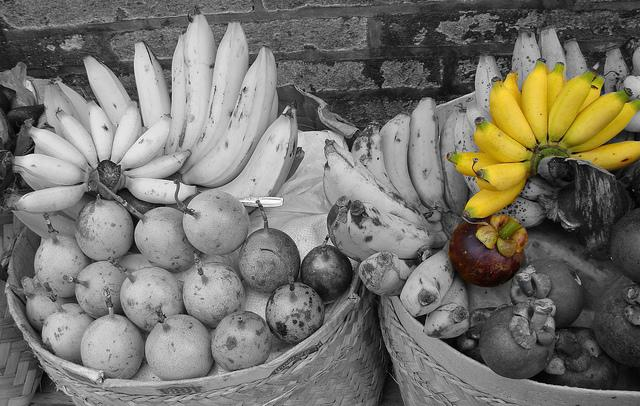Where is this produce located? Please explain your reasoning. market. The produce looks to be on display at an outdoor venue. 